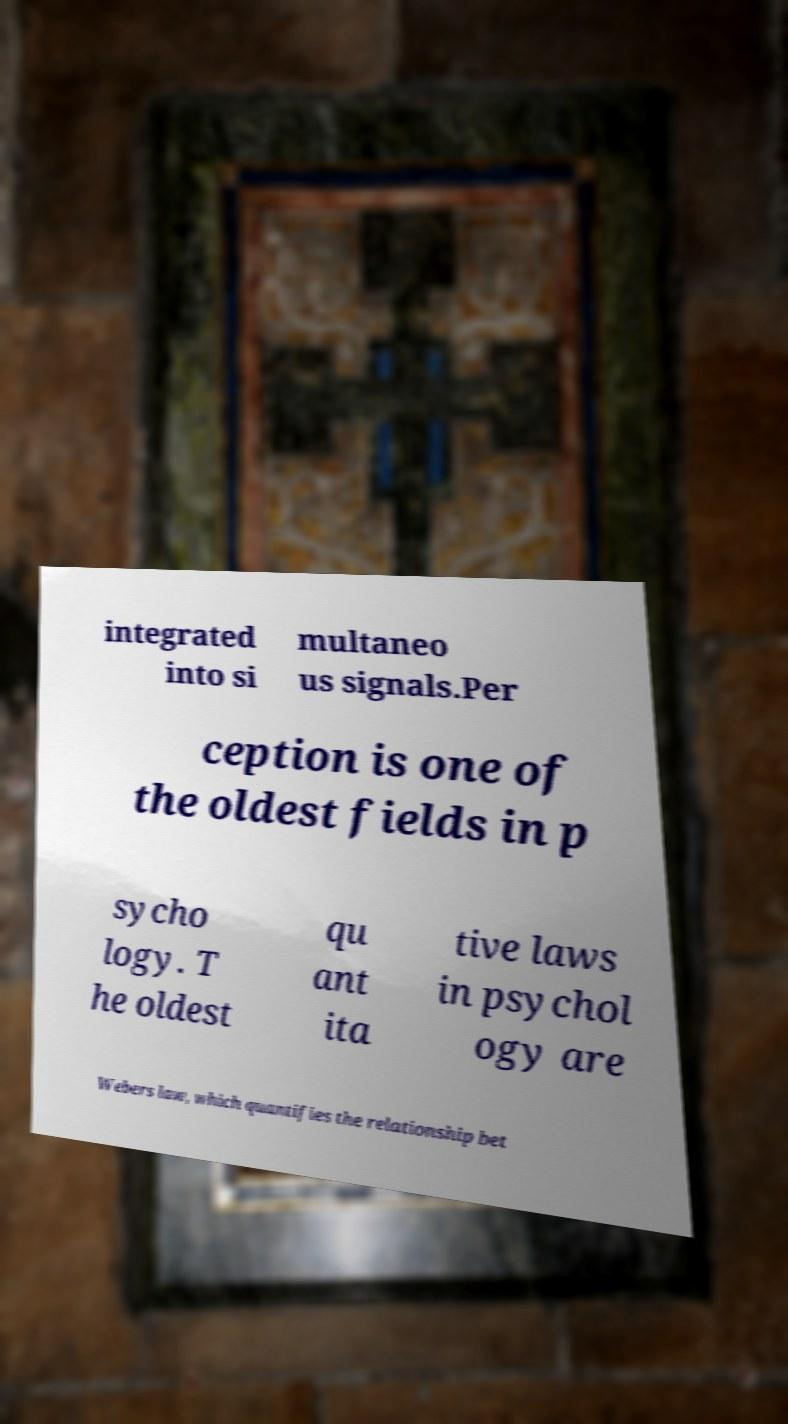Can you accurately transcribe the text from the provided image for me? integrated into si multaneo us signals.Per ception is one of the oldest fields in p sycho logy. T he oldest qu ant ita tive laws in psychol ogy are Webers law, which quantifies the relationship bet 